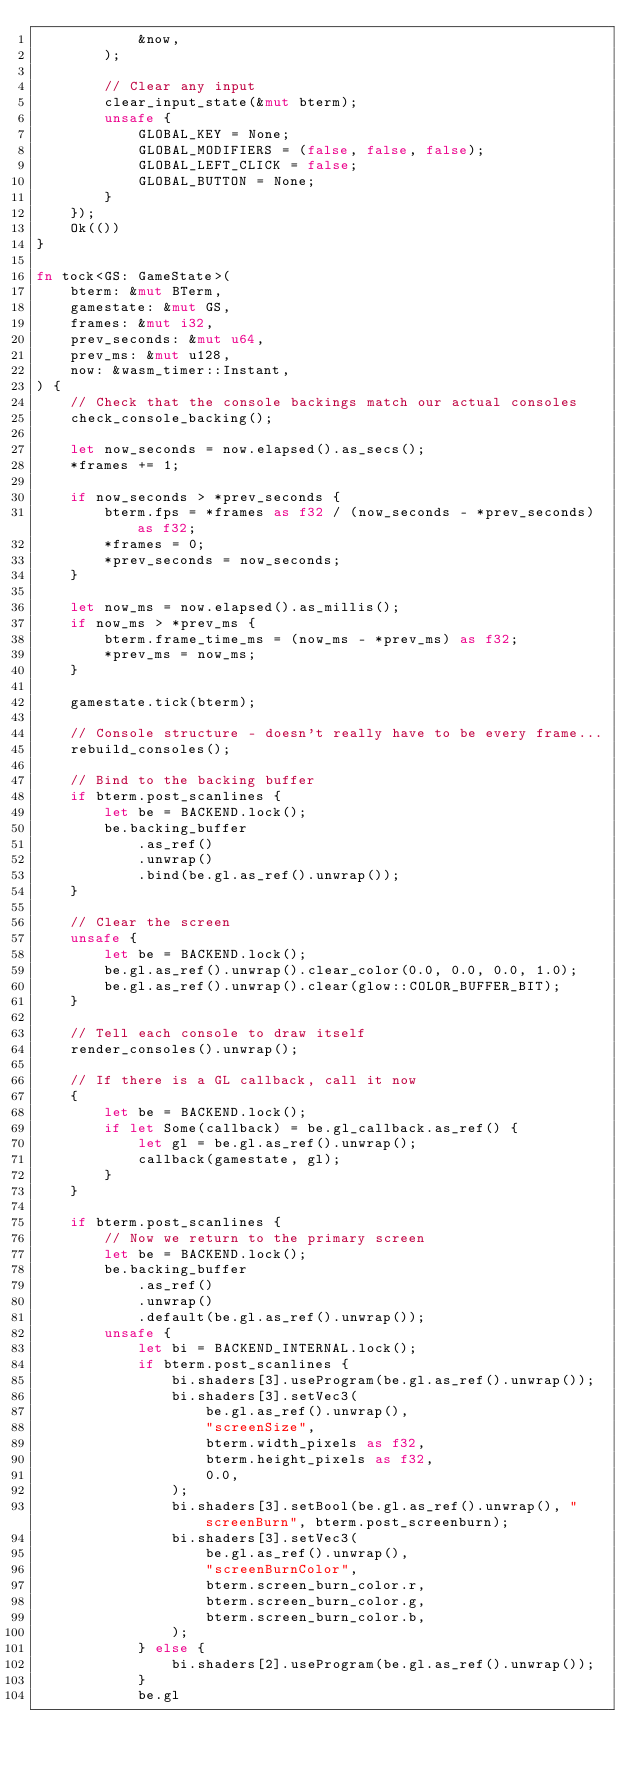Convert code to text. <code><loc_0><loc_0><loc_500><loc_500><_Rust_>            &now,
        );

        // Clear any input
        clear_input_state(&mut bterm);
        unsafe {
            GLOBAL_KEY = None;
            GLOBAL_MODIFIERS = (false, false, false);
            GLOBAL_LEFT_CLICK = false;
            GLOBAL_BUTTON = None;
        }
    });
    Ok(())
}

fn tock<GS: GameState>(
    bterm: &mut BTerm,
    gamestate: &mut GS,
    frames: &mut i32,
    prev_seconds: &mut u64,
    prev_ms: &mut u128,
    now: &wasm_timer::Instant,
) {
    // Check that the console backings match our actual consoles
    check_console_backing();

    let now_seconds = now.elapsed().as_secs();
    *frames += 1;

    if now_seconds > *prev_seconds {
        bterm.fps = *frames as f32 / (now_seconds - *prev_seconds) as f32;
        *frames = 0;
        *prev_seconds = now_seconds;
    }

    let now_ms = now.elapsed().as_millis();
    if now_ms > *prev_ms {
        bterm.frame_time_ms = (now_ms - *prev_ms) as f32;
        *prev_ms = now_ms;
    }

    gamestate.tick(bterm);

    // Console structure - doesn't really have to be every frame...
    rebuild_consoles();

    // Bind to the backing buffer
    if bterm.post_scanlines {
        let be = BACKEND.lock();
        be.backing_buffer
            .as_ref()
            .unwrap()
            .bind(be.gl.as_ref().unwrap());
    }

    // Clear the screen
    unsafe {
        let be = BACKEND.lock();
        be.gl.as_ref().unwrap().clear_color(0.0, 0.0, 0.0, 1.0);
        be.gl.as_ref().unwrap().clear(glow::COLOR_BUFFER_BIT);
    }

    // Tell each console to draw itself
    render_consoles().unwrap();

    // If there is a GL callback, call it now
    {
        let be = BACKEND.lock();
        if let Some(callback) = be.gl_callback.as_ref() {
            let gl = be.gl.as_ref().unwrap();
            callback(gamestate, gl);
        }
    }

    if bterm.post_scanlines {
        // Now we return to the primary screen
        let be = BACKEND.lock();
        be.backing_buffer
            .as_ref()
            .unwrap()
            .default(be.gl.as_ref().unwrap());
        unsafe {
            let bi = BACKEND_INTERNAL.lock();
            if bterm.post_scanlines {
                bi.shaders[3].useProgram(be.gl.as_ref().unwrap());
                bi.shaders[3].setVec3(
                    be.gl.as_ref().unwrap(),
                    "screenSize",
                    bterm.width_pixels as f32,
                    bterm.height_pixels as f32,
                    0.0,
                );
                bi.shaders[3].setBool(be.gl.as_ref().unwrap(), "screenBurn", bterm.post_screenburn);
                bi.shaders[3].setVec3(
                    be.gl.as_ref().unwrap(),
                    "screenBurnColor",
                    bterm.screen_burn_color.r,
                    bterm.screen_burn_color.g,
                    bterm.screen_burn_color.b,
                );
            } else {
                bi.shaders[2].useProgram(be.gl.as_ref().unwrap());
            }
            be.gl</code> 